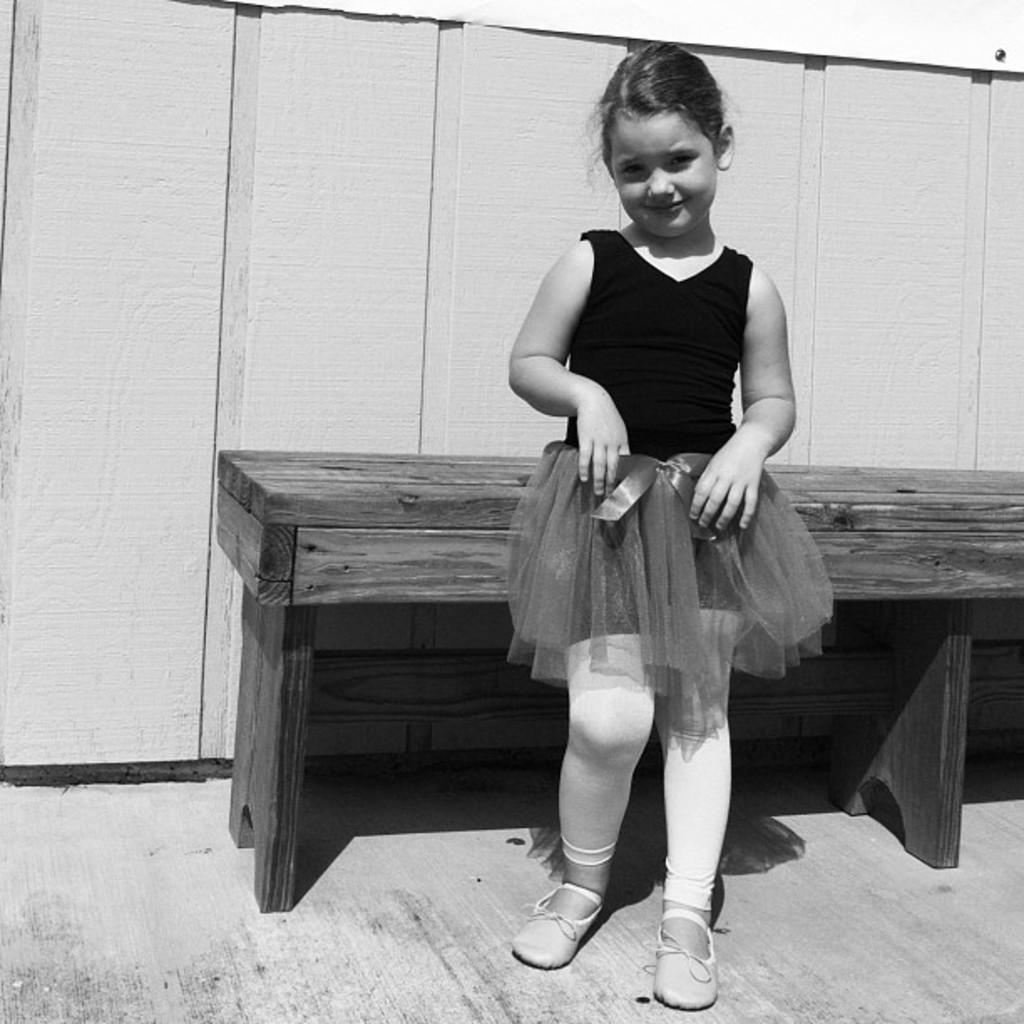Who is present in the image? There is a girl in the image. What is the girl doing in the image? The girl is standing beside a wooden bench. What can be seen in the background of the image? There is a wooden fence in the image. What type of drum is the girl playing in the image? There is no drum present in the image; the girl is standing beside a wooden bench. 